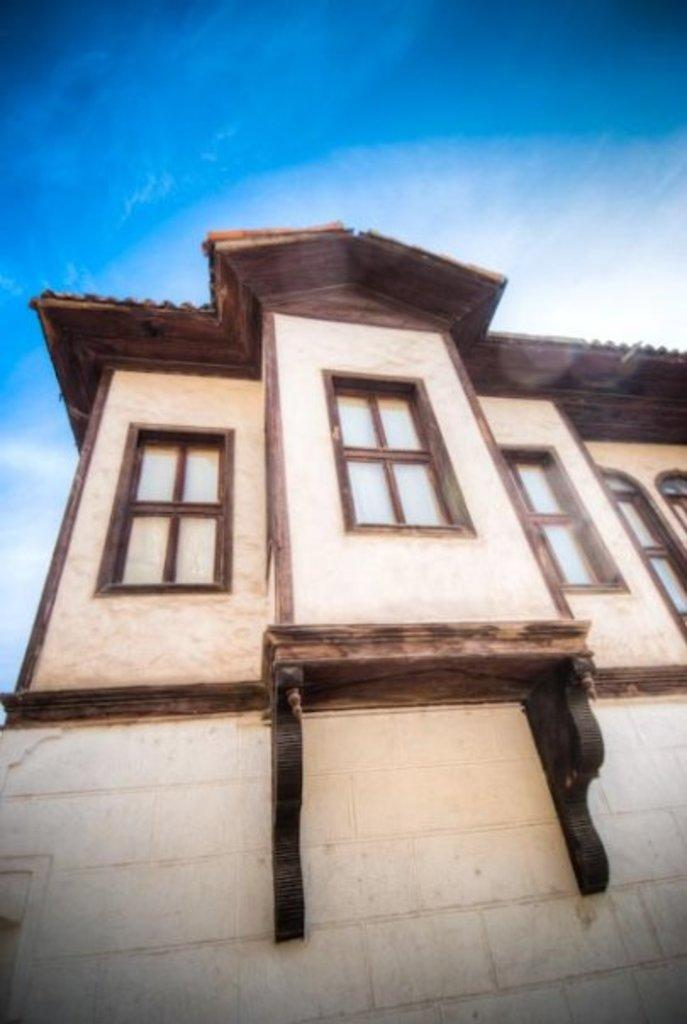What type of structure is present in the image? There is a building in the image. What features can be observed on the building? The building has windows and a roof. What is visible at the top of the image? The sky is visible at the top of the image. Can you tell me how many drums are being played on the roof of the building in the image? There are no drums or any indication of music being played in the image; it only features a building with windows and a roof. 